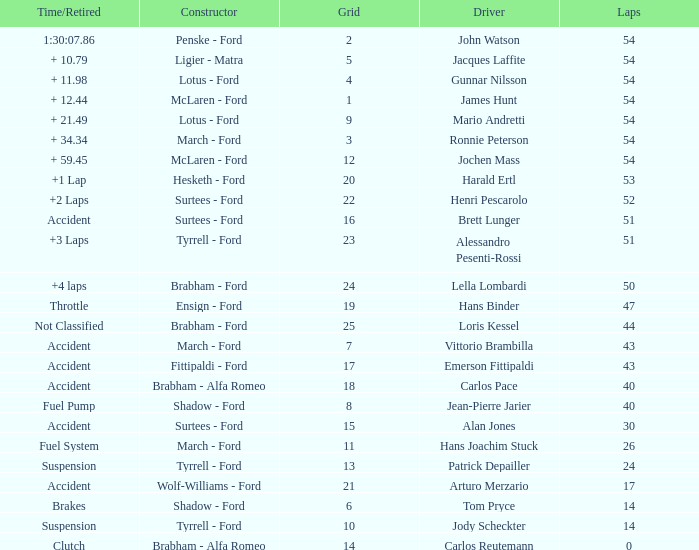How many laps did Emerson Fittipaldi do on a grid larger than 14, and when was the Time/Retired of accident? 1.0. 